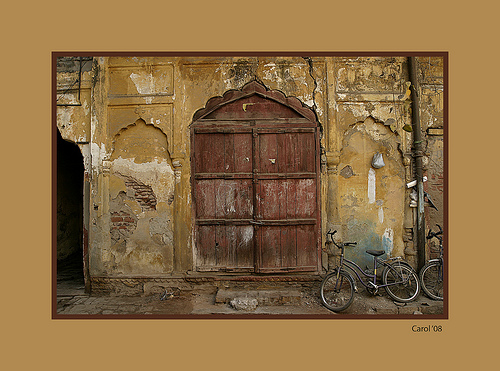Please provide a short description for this region: [0.39, 0.3, 0.64, 0.69]. The region depicts a robust brown door, rich in color and texture, standing against a backdrop of crumbling walls. 